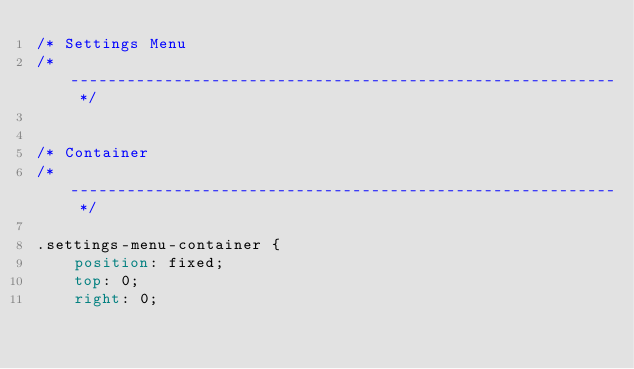<code> <loc_0><loc_0><loc_500><loc_500><_CSS_>/* Settings Menu
/* ---------------------------------------------------------- */


/* Container
/* ---------------------------------------------------------- */

.settings-menu-container {
    position: fixed;
    top: 0;
    right: 0;</code> 